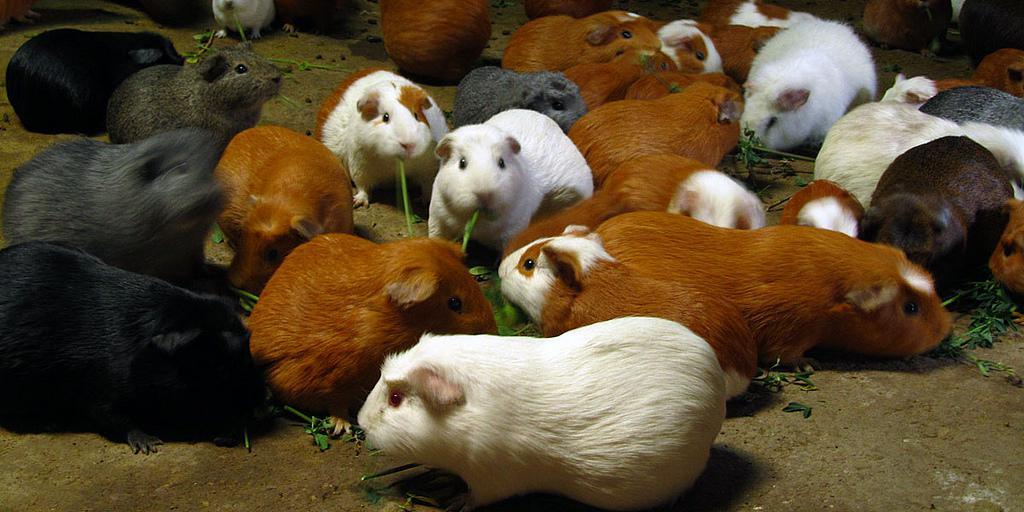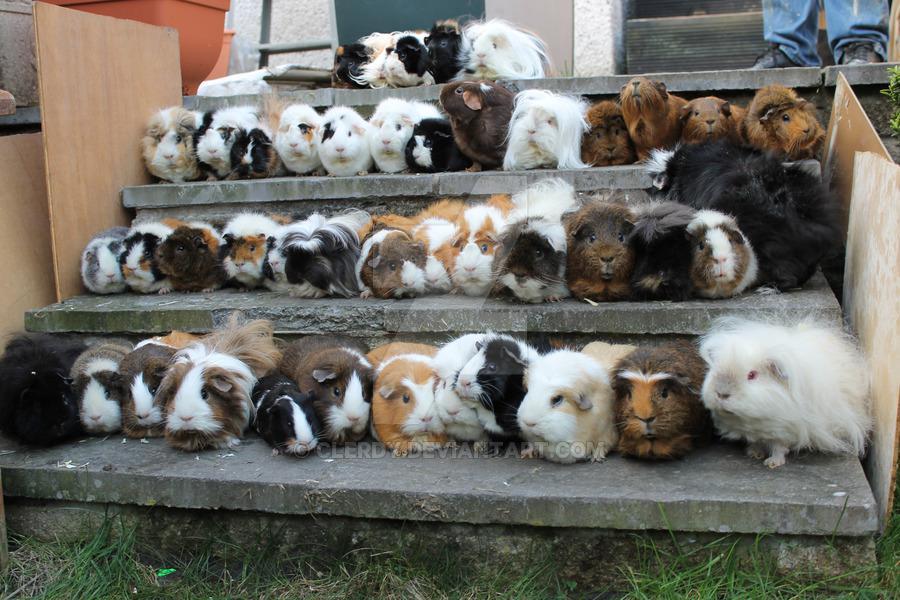The first image is the image on the left, the second image is the image on the right. Assess this claim about the two images: "There are no more than five animals in one of the images". Correct or not? Answer yes or no. No. The first image is the image on the left, the second image is the image on the right. For the images displayed, is the sentence "An image shows a horizontal row of no more than five hamsters." factually correct? Answer yes or no. No. 